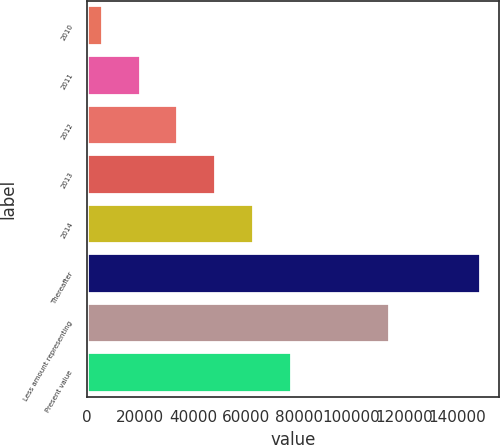<chart> <loc_0><loc_0><loc_500><loc_500><bar_chart><fcel>2010<fcel>2011<fcel>2012<fcel>2013<fcel>2014<fcel>Thereafter<fcel>Less amount representing<fcel>Present value<nl><fcel>5590<fcel>19874.8<fcel>34159.6<fcel>48444.4<fcel>62729.2<fcel>148438<fcel>114146<fcel>77014<nl></chart> 